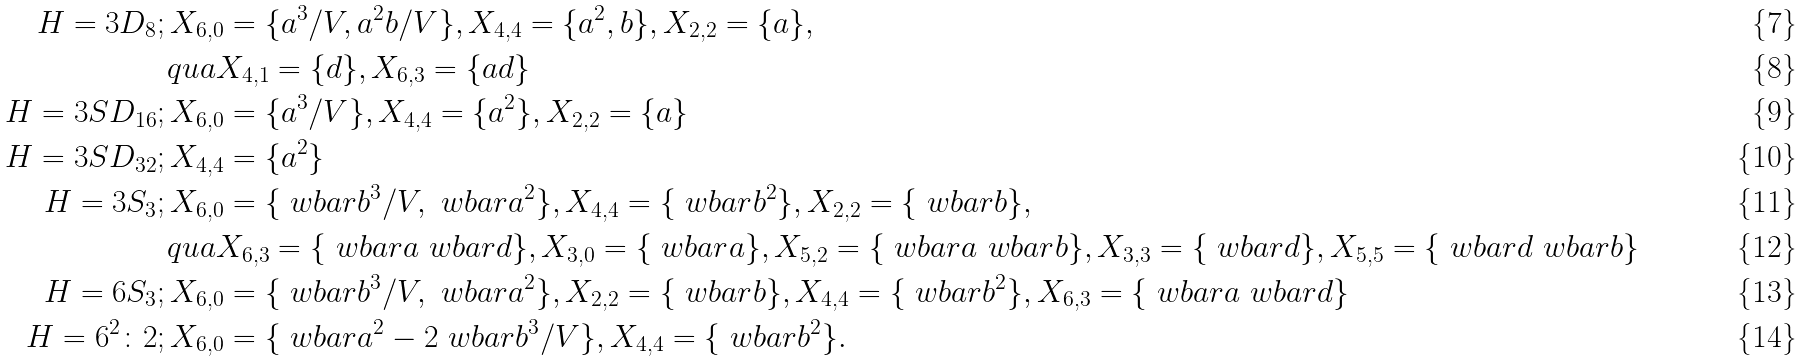Convert formula to latex. <formula><loc_0><loc_0><loc_500><loc_500>H = 3 D _ { 8 } & ; X _ { 6 , 0 } = \{ a ^ { 3 } / V , a ^ { 2 } b / V \} , X _ { 4 , 4 } = \{ a ^ { 2 } , b \} , X _ { 2 , 2 } = \{ a \} , \\ & \ q u a X _ { 4 , 1 } = \{ d \} , X _ { 6 , 3 } = \{ a d \} \\ H = 3 S D _ { 1 6 } & ; X _ { 6 , 0 } = \{ a ^ { 3 } / V \} , X _ { 4 , 4 } = \{ a ^ { 2 } \} , X _ { 2 , 2 } = \{ a \} \\ H = 3 S D _ { 3 2 } & ; X _ { 4 , 4 } = \{ a ^ { 2 } \} \\ H = 3 S _ { 3 } & ; X _ { 6 , 0 } = \{ \ w b a r b ^ { 3 } / V , \ w b a r a ^ { 2 } \} , X _ { 4 , 4 } = \{ \ w b a r b ^ { 2 } \} , X _ { 2 , 2 } = \{ \ w b a r b \} , \\ & \ q u a X _ { 6 , 3 } = \{ \ w b a r a \ w b a r d \} , X _ { 3 , 0 } = \{ \ w b a r a \} , X _ { 5 , 2 } = \{ \ w b a r a \ w b a r b \} , X _ { 3 , 3 } = \{ \ w b a r d \} , X _ { 5 , 5 } = \{ \ w b a r d \ w b a r b \} \\ H = 6 S _ { 3 } & ; X _ { 6 , 0 } = \{ \ w b a r b ^ { 3 } / V , \ w b a r a ^ { 2 } \} , X _ { 2 , 2 } = \{ \ w b a r b \} , X _ { 4 , 4 } = \{ \ w b a r b ^ { 2 } \} , X _ { 6 , 3 } = \{ \ w b a r a \ w b a r d \} \\ H = 6 ^ { 2 } { \colon } 2 & ; X _ { 6 , 0 } = \{ \ w b a r a ^ { 2 } - 2 \ w b a r b ^ { 3 } / V \} , X _ { 4 , 4 } = \{ \ w b a r b ^ { 2 } \} .</formula> 